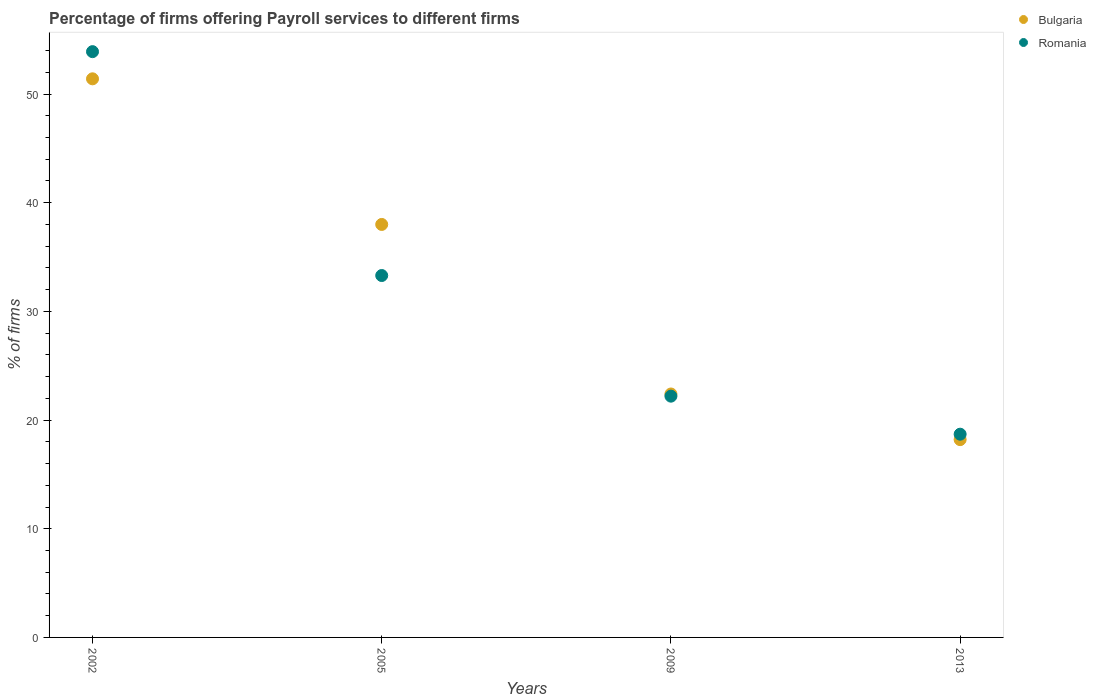Across all years, what is the maximum percentage of firms offering payroll services in Bulgaria?
Provide a succinct answer. 51.4. In which year was the percentage of firms offering payroll services in Bulgaria maximum?
Ensure brevity in your answer.  2002. In which year was the percentage of firms offering payroll services in Bulgaria minimum?
Offer a terse response. 2013. What is the total percentage of firms offering payroll services in Bulgaria in the graph?
Give a very brief answer. 130. What is the difference between the percentage of firms offering payroll services in Romania in 2002 and that in 2013?
Provide a succinct answer. 35.2. What is the average percentage of firms offering payroll services in Bulgaria per year?
Provide a succinct answer. 32.5. In the year 2002, what is the difference between the percentage of firms offering payroll services in Bulgaria and percentage of firms offering payroll services in Romania?
Provide a succinct answer. -2.5. In how many years, is the percentage of firms offering payroll services in Romania greater than 50 %?
Your answer should be compact. 1. What is the ratio of the percentage of firms offering payroll services in Romania in 2005 to that in 2013?
Ensure brevity in your answer.  1.78. What is the difference between the highest and the second highest percentage of firms offering payroll services in Romania?
Ensure brevity in your answer.  20.6. What is the difference between the highest and the lowest percentage of firms offering payroll services in Romania?
Offer a very short reply. 35.2. Is the sum of the percentage of firms offering payroll services in Romania in 2009 and 2013 greater than the maximum percentage of firms offering payroll services in Bulgaria across all years?
Keep it short and to the point. No. Does the percentage of firms offering payroll services in Romania monotonically increase over the years?
Provide a short and direct response. No. Is the percentage of firms offering payroll services in Bulgaria strictly greater than the percentage of firms offering payroll services in Romania over the years?
Ensure brevity in your answer.  No. Where does the legend appear in the graph?
Provide a short and direct response. Top right. How many legend labels are there?
Your answer should be very brief. 2. How are the legend labels stacked?
Provide a short and direct response. Vertical. What is the title of the graph?
Your answer should be compact. Percentage of firms offering Payroll services to different firms. What is the label or title of the Y-axis?
Keep it short and to the point. % of firms. What is the % of firms of Bulgaria in 2002?
Offer a terse response. 51.4. What is the % of firms of Romania in 2002?
Provide a succinct answer. 53.9. What is the % of firms of Bulgaria in 2005?
Your response must be concise. 38. What is the % of firms in Romania in 2005?
Offer a very short reply. 33.3. What is the % of firms of Bulgaria in 2009?
Keep it short and to the point. 22.4. What is the % of firms of Romania in 2009?
Keep it short and to the point. 22.2. What is the % of firms in Bulgaria in 2013?
Offer a very short reply. 18.2. What is the % of firms of Romania in 2013?
Your response must be concise. 18.7. Across all years, what is the maximum % of firms in Bulgaria?
Offer a terse response. 51.4. Across all years, what is the maximum % of firms of Romania?
Give a very brief answer. 53.9. Across all years, what is the minimum % of firms of Romania?
Keep it short and to the point. 18.7. What is the total % of firms in Bulgaria in the graph?
Offer a terse response. 130. What is the total % of firms of Romania in the graph?
Give a very brief answer. 128.1. What is the difference between the % of firms in Bulgaria in 2002 and that in 2005?
Give a very brief answer. 13.4. What is the difference between the % of firms of Romania in 2002 and that in 2005?
Give a very brief answer. 20.6. What is the difference between the % of firms of Bulgaria in 2002 and that in 2009?
Your answer should be very brief. 29. What is the difference between the % of firms of Romania in 2002 and that in 2009?
Your answer should be compact. 31.7. What is the difference between the % of firms of Bulgaria in 2002 and that in 2013?
Offer a terse response. 33.2. What is the difference between the % of firms in Romania in 2002 and that in 2013?
Offer a terse response. 35.2. What is the difference between the % of firms of Bulgaria in 2005 and that in 2013?
Give a very brief answer. 19.8. What is the difference between the % of firms in Romania in 2009 and that in 2013?
Provide a short and direct response. 3.5. What is the difference between the % of firms of Bulgaria in 2002 and the % of firms of Romania in 2005?
Provide a short and direct response. 18.1. What is the difference between the % of firms of Bulgaria in 2002 and the % of firms of Romania in 2009?
Make the answer very short. 29.2. What is the difference between the % of firms in Bulgaria in 2002 and the % of firms in Romania in 2013?
Your answer should be compact. 32.7. What is the difference between the % of firms in Bulgaria in 2005 and the % of firms in Romania in 2013?
Keep it short and to the point. 19.3. What is the difference between the % of firms in Bulgaria in 2009 and the % of firms in Romania in 2013?
Provide a short and direct response. 3.7. What is the average % of firms in Bulgaria per year?
Provide a succinct answer. 32.5. What is the average % of firms of Romania per year?
Your response must be concise. 32.02. In the year 2005, what is the difference between the % of firms of Bulgaria and % of firms of Romania?
Ensure brevity in your answer.  4.7. What is the ratio of the % of firms of Bulgaria in 2002 to that in 2005?
Provide a succinct answer. 1.35. What is the ratio of the % of firms of Romania in 2002 to that in 2005?
Ensure brevity in your answer.  1.62. What is the ratio of the % of firms in Bulgaria in 2002 to that in 2009?
Provide a succinct answer. 2.29. What is the ratio of the % of firms of Romania in 2002 to that in 2009?
Give a very brief answer. 2.43. What is the ratio of the % of firms of Bulgaria in 2002 to that in 2013?
Ensure brevity in your answer.  2.82. What is the ratio of the % of firms in Romania in 2002 to that in 2013?
Provide a short and direct response. 2.88. What is the ratio of the % of firms of Bulgaria in 2005 to that in 2009?
Keep it short and to the point. 1.7. What is the ratio of the % of firms in Bulgaria in 2005 to that in 2013?
Give a very brief answer. 2.09. What is the ratio of the % of firms of Romania in 2005 to that in 2013?
Your response must be concise. 1.78. What is the ratio of the % of firms in Bulgaria in 2009 to that in 2013?
Ensure brevity in your answer.  1.23. What is the ratio of the % of firms in Romania in 2009 to that in 2013?
Offer a very short reply. 1.19. What is the difference between the highest and the second highest % of firms of Bulgaria?
Provide a short and direct response. 13.4. What is the difference between the highest and the second highest % of firms in Romania?
Provide a succinct answer. 20.6. What is the difference between the highest and the lowest % of firms in Bulgaria?
Provide a short and direct response. 33.2. What is the difference between the highest and the lowest % of firms in Romania?
Your response must be concise. 35.2. 